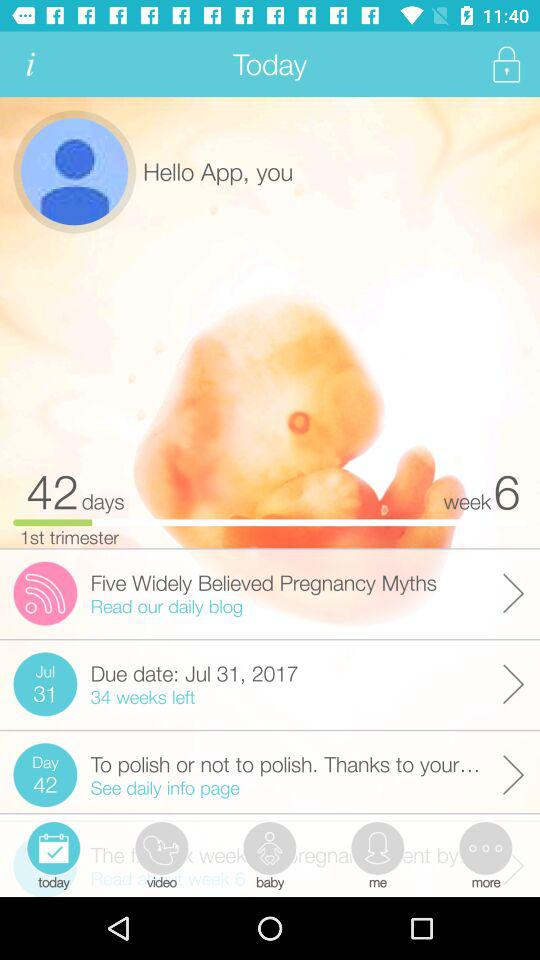What is the total number of days? The total number of days is 42. 